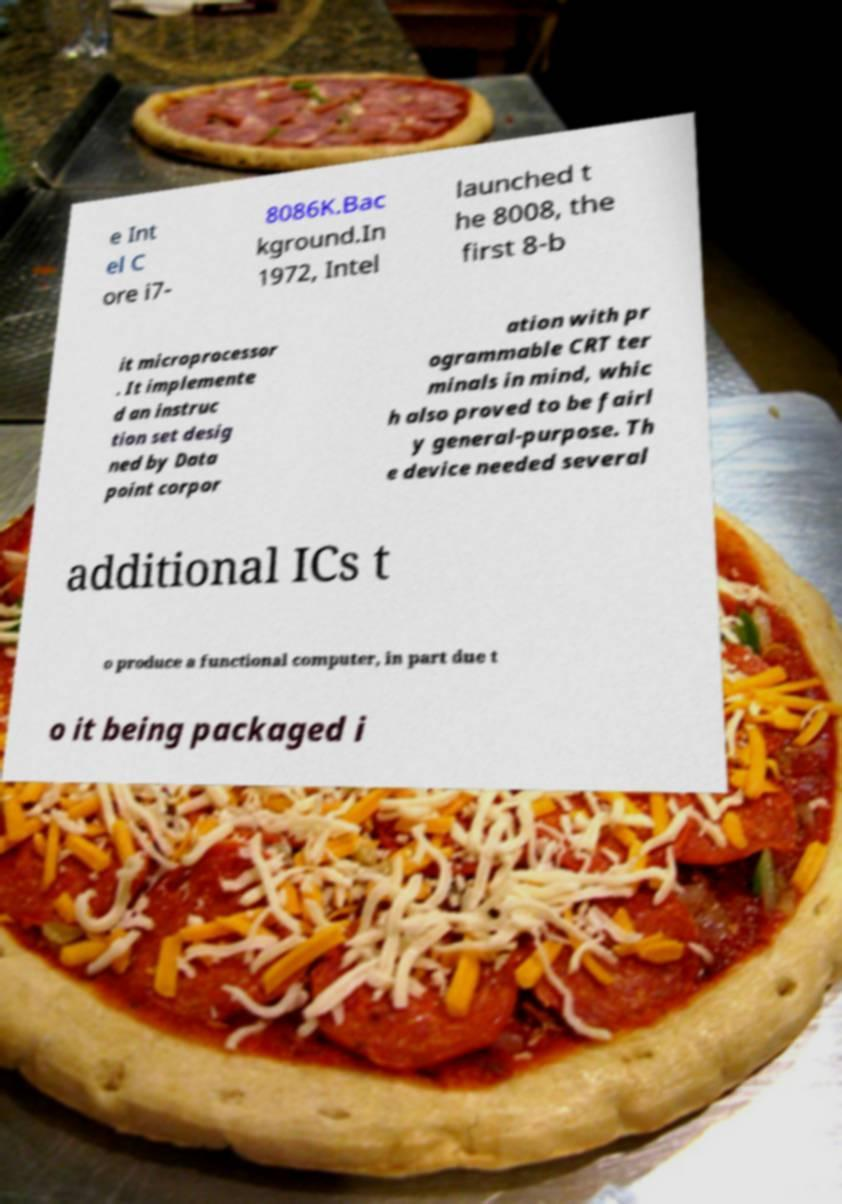Can you read and provide the text displayed in the image?This photo seems to have some interesting text. Can you extract and type it out for me? e Int el C ore i7- 8086K.Bac kground.In 1972, Intel launched t he 8008, the first 8-b it microprocessor . It implemente d an instruc tion set desig ned by Data point corpor ation with pr ogrammable CRT ter minals in mind, whic h also proved to be fairl y general-purpose. Th e device needed several additional ICs t o produce a functional computer, in part due t o it being packaged i 